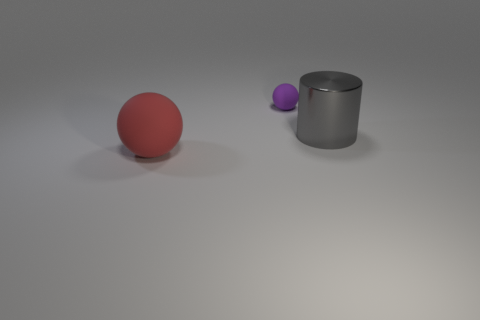What material do the objects in the image seem to be made of? The large red and small purple objects appear to be made of rubber given their matte surfaces, while the big metal cylinder has a shiny surface that suggests it is metallic. 